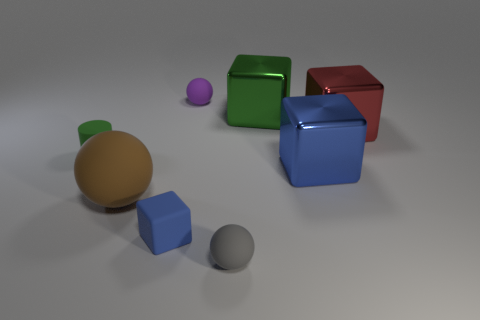How many objects are there in total, and can you describe their colors? There are a total of six objects in the image. Starting from the closest to the furthest, there is a small blue cube, a larger green cube, a tiny gray rubber ball, a large brown sphere, a purple sphere, and a large red cube. 